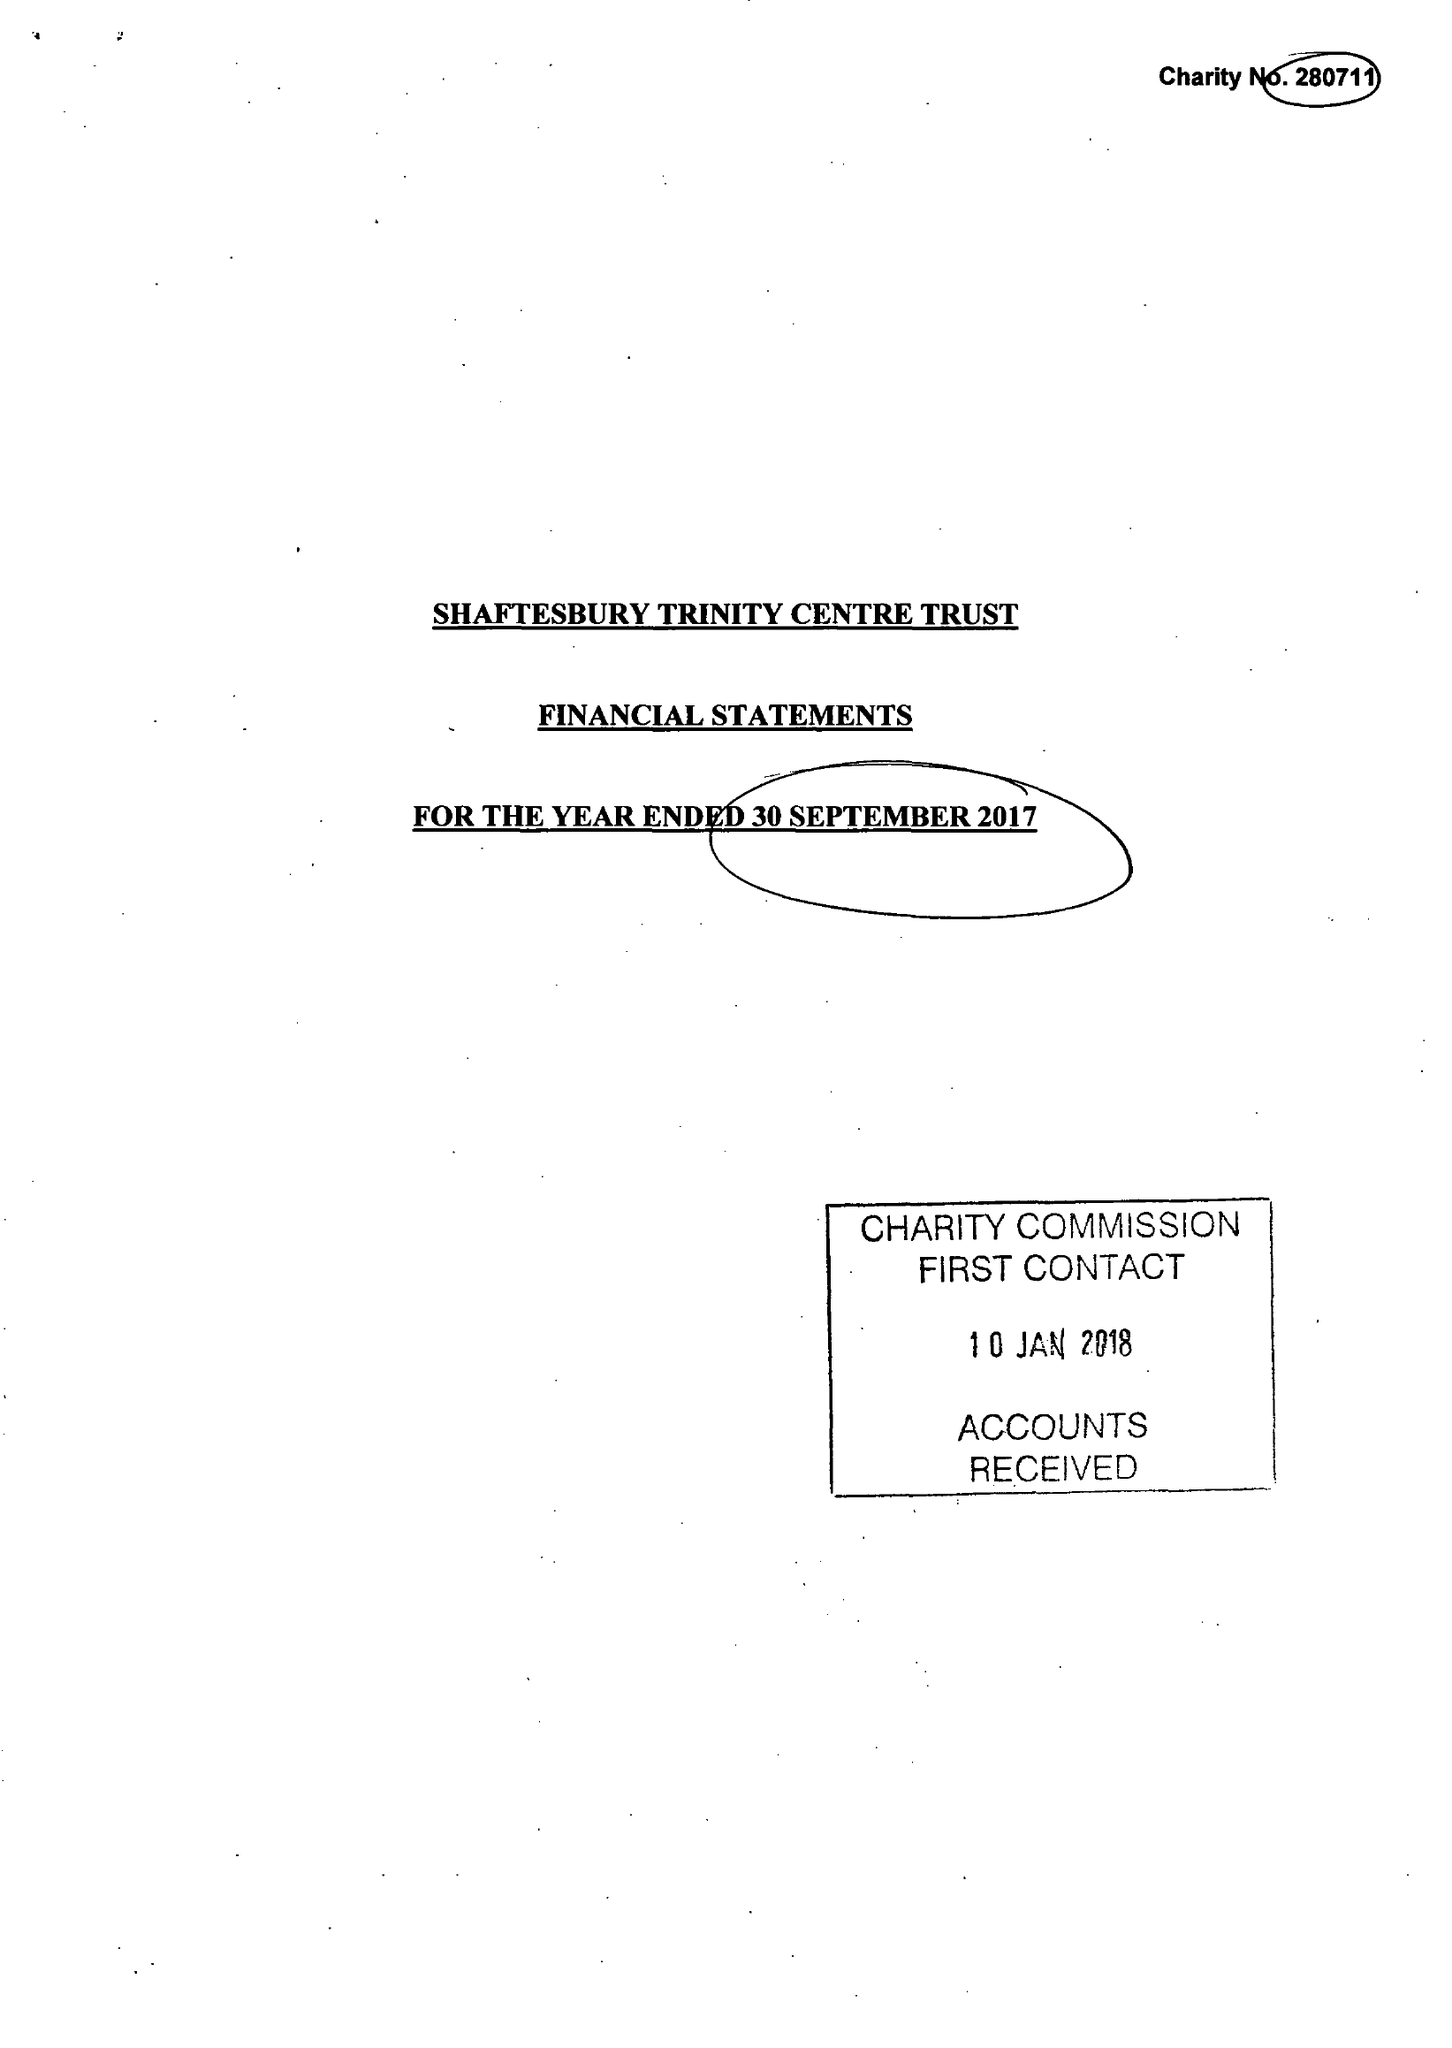What is the value for the spending_annually_in_british_pounds?
Answer the question using a single word or phrase. 149108.00 